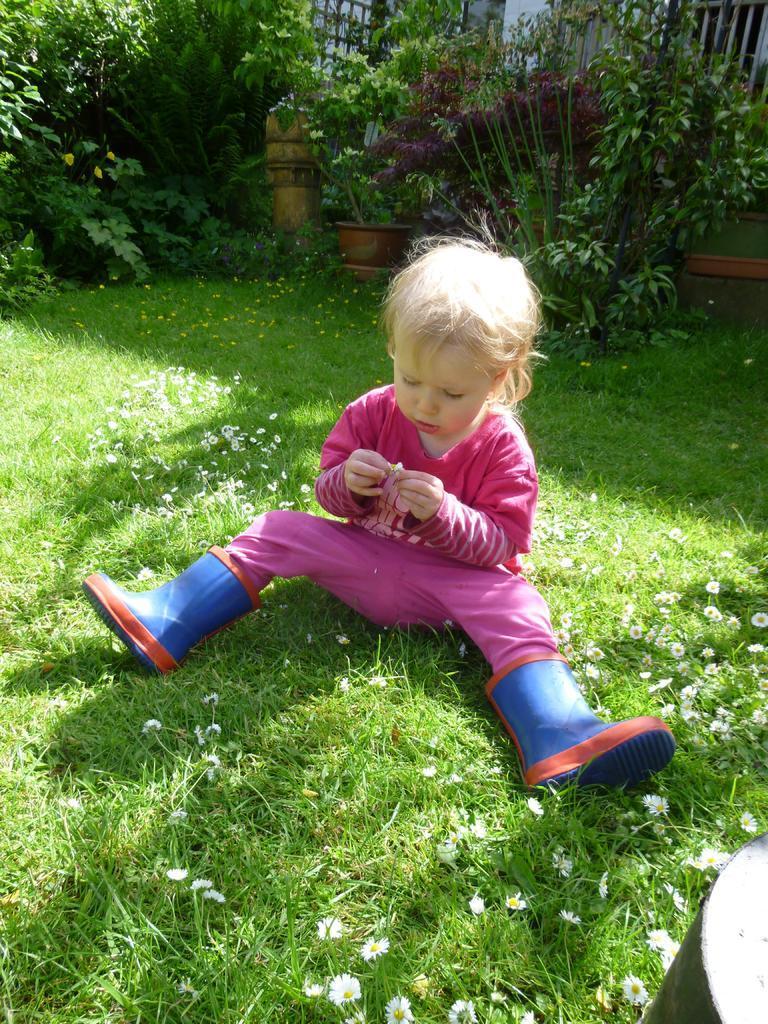Describe this image in one or two sentences. This is a girl sitting on the grass. I can see the tiny flowers, which are white in color. This looks like a flower pot with a plant. These are the trees. In the background, I can see an iron grill. 